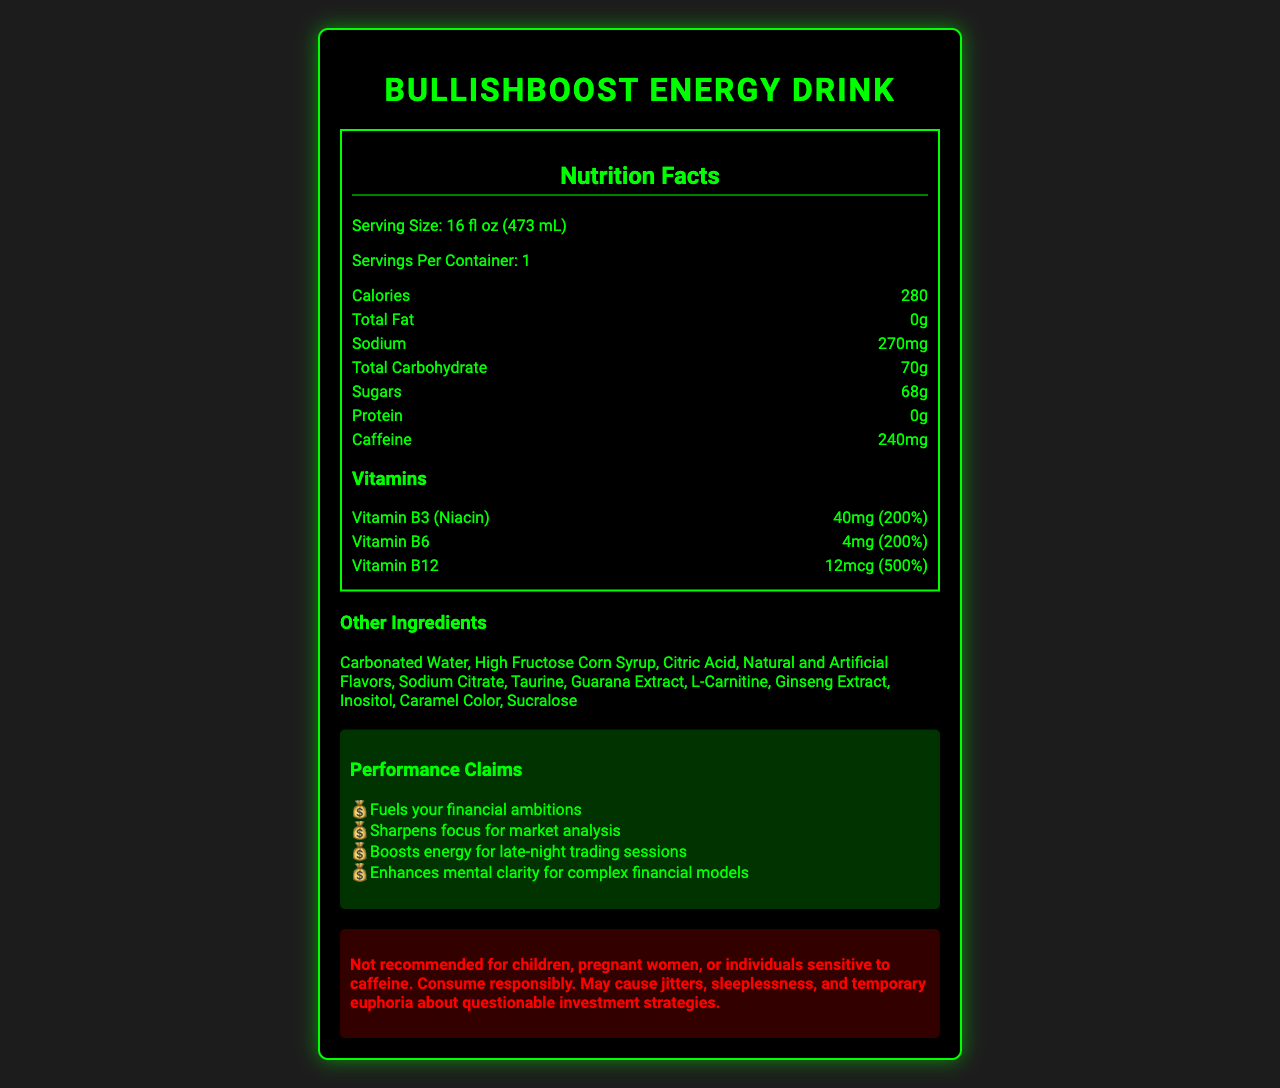What is the serving size of BullishBoost Energy Drink? The serving size is explicitly stated as "16 fl oz (473 mL)" in the document.
Answer: 16 fl oz (473 mL) How many calories are in one serving? The document lists the calories per serving as 280.
Answer: 280 How many servings are there per container? The document specifies that there is 1 serving per container.
Answer: 1 What amount of Vitamin B12 does this energy drink contain? The document lists the amount of Vitamin B12 as 12mcg.
Answer: 12mcg What is the caffeine content per serving? The document specifies that the caffeine content per serving is 240mg.
Answer: 240mg What are the main ingredients in BullishBoost Energy Drink? The document lists the main ingredients under the "Other Ingredients" section.
Answer: Carbonated Water, High Fructose Corn Syrup, Citric Acid, Natural and Artificial Flavors, Sodium Citrate, Taurine, Guarana Extract, L-Carnitine, Ginseng Extract, Inositol, Caramel Color, Sucralose How much sodium is in one serving of BullishBoost Energy Drink? A. 150mg B. 210mg C. 270mg D. 300mg The document lists the sodium content as 270mg per serving.
Answer: C Which vitamin has the highest daily value percentage in BullishBoost Energy Drink? A. Vitamin B1 B. Vitamin B3 (Niacin) C. Vitamin B6 D. Vitamin B12 The Vitamin B12 has a daily value percentage of 500%, the highest among the listed vitamins.
Answer: D Is BullishBoost Energy Drink recommended for children or pregnant women? The warning statement in the document clearly states that it is not recommended for children or pregnant women.
Answer: No Summarize the main features and claims of BullishBoost Energy Drink. This answer encapsulates the main nutritional information, the marketing claims, the primary ingredients, and the warnings as presented in the document.
Answer: BullishBoost Energy Drink is a high-calorie beverage marketed as a "Performance Enhancer" for long work hours, containing 280 calories per serving with significant amounts of sugar and caffeine. It includes vitamins like B3, B6, and B12 with high daily value percentages and is promoted for enhancing focus and mental clarity for financial tasks. Important ingredients include carbonated water, high fructose corn syrup, and guarana extract. There is a warning against children, pregnant women, and individuals sensitive to caffeine. What impact does high fructose corn syrup have on health? The document lists high fructose corn syrup as an ingredient but does not provide information on its health impacts.
Answer: Cannot be determined 